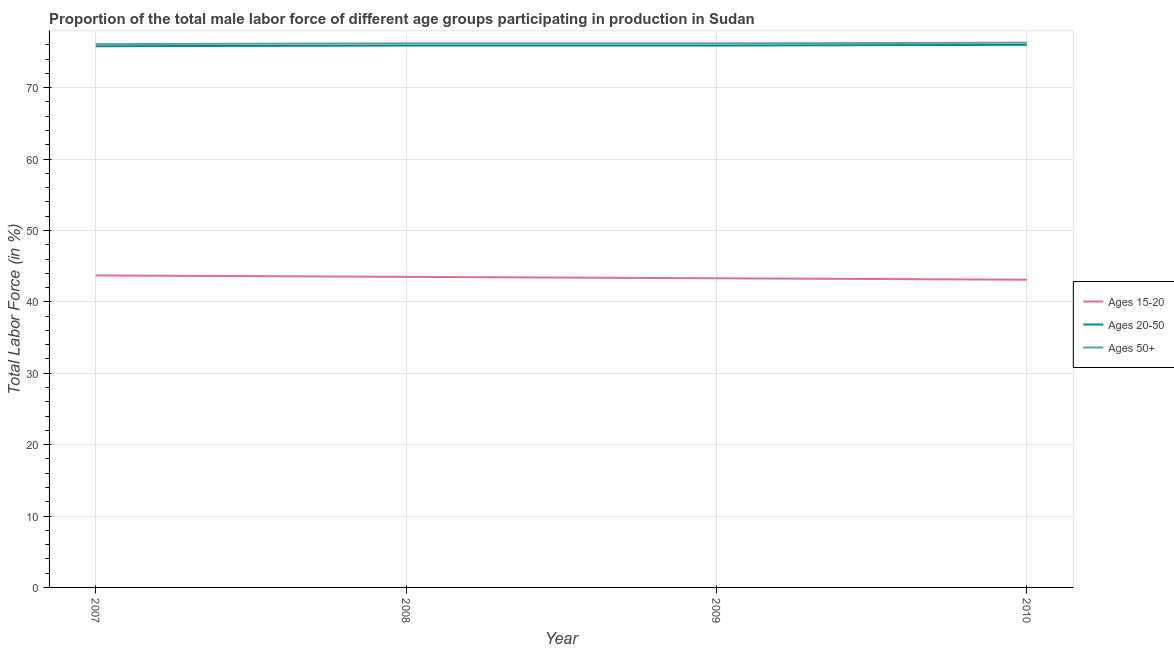What is the percentage of male labor force within the age group 15-20 in 2008?
Give a very brief answer. 43.5. Across all years, what is the maximum percentage of male labor force within the age group 20-50?
Provide a short and direct response. 76. Across all years, what is the minimum percentage of male labor force within the age group 20-50?
Your response must be concise. 75.8. In which year was the percentage of male labor force within the age group 20-50 minimum?
Offer a very short reply. 2007. What is the total percentage of male labor force above age 50 in the graph?
Keep it short and to the point. 304.8. What is the difference between the percentage of male labor force above age 50 in 2009 and that in 2010?
Make the answer very short. -0.1. What is the difference between the percentage of male labor force above age 50 in 2007 and the percentage of male labor force within the age group 20-50 in 2008?
Give a very brief answer. 0.2. What is the average percentage of male labor force above age 50 per year?
Offer a very short reply. 76.2. In the year 2008, what is the difference between the percentage of male labor force within the age group 15-20 and percentage of male labor force within the age group 20-50?
Provide a succinct answer. -32.4. In how many years, is the percentage of male labor force above age 50 greater than 20 %?
Make the answer very short. 4. What is the ratio of the percentage of male labor force within the age group 20-50 in 2007 to that in 2010?
Your response must be concise. 1. Is the percentage of male labor force within the age group 20-50 in 2009 less than that in 2010?
Give a very brief answer. Yes. Is the difference between the percentage of male labor force within the age group 15-20 in 2007 and 2010 greater than the difference between the percentage of male labor force within the age group 20-50 in 2007 and 2010?
Keep it short and to the point. Yes. What is the difference between the highest and the second highest percentage of male labor force above age 50?
Make the answer very short. 0.1. What is the difference between the highest and the lowest percentage of male labor force above age 50?
Offer a very short reply. 0.2. In how many years, is the percentage of male labor force within the age group 15-20 greater than the average percentage of male labor force within the age group 15-20 taken over all years?
Your response must be concise. 2. Does the percentage of male labor force within the age group 20-50 monotonically increase over the years?
Offer a terse response. No. Is the percentage of male labor force within the age group 20-50 strictly less than the percentage of male labor force within the age group 15-20 over the years?
Give a very brief answer. No. How many years are there in the graph?
Your answer should be very brief. 4. What is the difference between two consecutive major ticks on the Y-axis?
Give a very brief answer. 10. Does the graph contain any zero values?
Make the answer very short. No. Does the graph contain grids?
Your answer should be very brief. Yes. How are the legend labels stacked?
Your answer should be compact. Vertical. What is the title of the graph?
Keep it short and to the point. Proportion of the total male labor force of different age groups participating in production in Sudan. Does "Fuel" appear as one of the legend labels in the graph?
Provide a short and direct response. No. What is the Total Labor Force (in %) of Ages 15-20 in 2007?
Keep it short and to the point. 43.7. What is the Total Labor Force (in %) in Ages 20-50 in 2007?
Ensure brevity in your answer.  75.8. What is the Total Labor Force (in %) in Ages 50+ in 2007?
Provide a succinct answer. 76.1. What is the Total Labor Force (in %) of Ages 15-20 in 2008?
Keep it short and to the point. 43.5. What is the Total Labor Force (in %) of Ages 20-50 in 2008?
Offer a very short reply. 75.9. What is the Total Labor Force (in %) in Ages 50+ in 2008?
Keep it short and to the point. 76.2. What is the Total Labor Force (in %) of Ages 15-20 in 2009?
Give a very brief answer. 43.3. What is the Total Labor Force (in %) in Ages 20-50 in 2009?
Your response must be concise. 75.9. What is the Total Labor Force (in %) of Ages 50+ in 2009?
Your response must be concise. 76.2. What is the Total Labor Force (in %) in Ages 15-20 in 2010?
Provide a short and direct response. 43.1. What is the Total Labor Force (in %) of Ages 20-50 in 2010?
Provide a short and direct response. 76. What is the Total Labor Force (in %) in Ages 50+ in 2010?
Your answer should be very brief. 76.3. Across all years, what is the maximum Total Labor Force (in %) of Ages 15-20?
Make the answer very short. 43.7. Across all years, what is the maximum Total Labor Force (in %) in Ages 20-50?
Make the answer very short. 76. Across all years, what is the maximum Total Labor Force (in %) of Ages 50+?
Keep it short and to the point. 76.3. Across all years, what is the minimum Total Labor Force (in %) of Ages 15-20?
Offer a terse response. 43.1. Across all years, what is the minimum Total Labor Force (in %) in Ages 20-50?
Your answer should be compact. 75.8. Across all years, what is the minimum Total Labor Force (in %) of Ages 50+?
Provide a succinct answer. 76.1. What is the total Total Labor Force (in %) in Ages 15-20 in the graph?
Your answer should be very brief. 173.6. What is the total Total Labor Force (in %) of Ages 20-50 in the graph?
Make the answer very short. 303.6. What is the total Total Labor Force (in %) in Ages 50+ in the graph?
Your answer should be very brief. 304.8. What is the difference between the Total Labor Force (in %) in Ages 15-20 in 2007 and that in 2008?
Your answer should be compact. 0.2. What is the difference between the Total Labor Force (in %) of Ages 20-50 in 2007 and that in 2009?
Offer a very short reply. -0.1. What is the difference between the Total Labor Force (in %) in Ages 50+ in 2007 and that in 2009?
Provide a short and direct response. -0.1. What is the difference between the Total Labor Force (in %) in Ages 15-20 in 2007 and that in 2010?
Your answer should be compact. 0.6. What is the difference between the Total Labor Force (in %) in Ages 20-50 in 2007 and that in 2010?
Ensure brevity in your answer.  -0.2. What is the difference between the Total Labor Force (in %) of Ages 50+ in 2007 and that in 2010?
Provide a succinct answer. -0.2. What is the difference between the Total Labor Force (in %) of Ages 15-20 in 2008 and that in 2009?
Your answer should be very brief. 0.2. What is the difference between the Total Labor Force (in %) of Ages 50+ in 2008 and that in 2009?
Your answer should be very brief. 0. What is the difference between the Total Labor Force (in %) in Ages 15-20 in 2008 and that in 2010?
Keep it short and to the point. 0.4. What is the difference between the Total Labor Force (in %) of Ages 20-50 in 2008 and that in 2010?
Make the answer very short. -0.1. What is the difference between the Total Labor Force (in %) in Ages 15-20 in 2009 and that in 2010?
Provide a succinct answer. 0.2. What is the difference between the Total Labor Force (in %) of Ages 20-50 in 2009 and that in 2010?
Ensure brevity in your answer.  -0.1. What is the difference between the Total Labor Force (in %) in Ages 15-20 in 2007 and the Total Labor Force (in %) in Ages 20-50 in 2008?
Provide a succinct answer. -32.2. What is the difference between the Total Labor Force (in %) in Ages 15-20 in 2007 and the Total Labor Force (in %) in Ages 50+ in 2008?
Offer a terse response. -32.5. What is the difference between the Total Labor Force (in %) of Ages 15-20 in 2007 and the Total Labor Force (in %) of Ages 20-50 in 2009?
Ensure brevity in your answer.  -32.2. What is the difference between the Total Labor Force (in %) of Ages 15-20 in 2007 and the Total Labor Force (in %) of Ages 50+ in 2009?
Ensure brevity in your answer.  -32.5. What is the difference between the Total Labor Force (in %) of Ages 15-20 in 2007 and the Total Labor Force (in %) of Ages 20-50 in 2010?
Your answer should be compact. -32.3. What is the difference between the Total Labor Force (in %) of Ages 15-20 in 2007 and the Total Labor Force (in %) of Ages 50+ in 2010?
Give a very brief answer. -32.6. What is the difference between the Total Labor Force (in %) of Ages 15-20 in 2008 and the Total Labor Force (in %) of Ages 20-50 in 2009?
Offer a terse response. -32.4. What is the difference between the Total Labor Force (in %) of Ages 15-20 in 2008 and the Total Labor Force (in %) of Ages 50+ in 2009?
Your answer should be compact. -32.7. What is the difference between the Total Labor Force (in %) in Ages 15-20 in 2008 and the Total Labor Force (in %) in Ages 20-50 in 2010?
Your answer should be compact. -32.5. What is the difference between the Total Labor Force (in %) in Ages 15-20 in 2008 and the Total Labor Force (in %) in Ages 50+ in 2010?
Your answer should be very brief. -32.8. What is the difference between the Total Labor Force (in %) in Ages 15-20 in 2009 and the Total Labor Force (in %) in Ages 20-50 in 2010?
Keep it short and to the point. -32.7. What is the difference between the Total Labor Force (in %) of Ages 15-20 in 2009 and the Total Labor Force (in %) of Ages 50+ in 2010?
Your answer should be very brief. -33. What is the average Total Labor Force (in %) in Ages 15-20 per year?
Ensure brevity in your answer.  43.4. What is the average Total Labor Force (in %) in Ages 20-50 per year?
Make the answer very short. 75.9. What is the average Total Labor Force (in %) in Ages 50+ per year?
Your response must be concise. 76.2. In the year 2007, what is the difference between the Total Labor Force (in %) of Ages 15-20 and Total Labor Force (in %) of Ages 20-50?
Ensure brevity in your answer.  -32.1. In the year 2007, what is the difference between the Total Labor Force (in %) of Ages 15-20 and Total Labor Force (in %) of Ages 50+?
Make the answer very short. -32.4. In the year 2007, what is the difference between the Total Labor Force (in %) of Ages 20-50 and Total Labor Force (in %) of Ages 50+?
Your answer should be very brief. -0.3. In the year 2008, what is the difference between the Total Labor Force (in %) of Ages 15-20 and Total Labor Force (in %) of Ages 20-50?
Offer a very short reply. -32.4. In the year 2008, what is the difference between the Total Labor Force (in %) in Ages 15-20 and Total Labor Force (in %) in Ages 50+?
Your answer should be compact. -32.7. In the year 2008, what is the difference between the Total Labor Force (in %) in Ages 20-50 and Total Labor Force (in %) in Ages 50+?
Offer a very short reply. -0.3. In the year 2009, what is the difference between the Total Labor Force (in %) of Ages 15-20 and Total Labor Force (in %) of Ages 20-50?
Provide a succinct answer. -32.6. In the year 2009, what is the difference between the Total Labor Force (in %) in Ages 15-20 and Total Labor Force (in %) in Ages 50+?
Your answer should be very brief. -32.9. In the year 2010, what is the difference between the Total Labor Force (in %) in Ages 15-20 and Total Labor Force (in %) in Ages 20-50?
Provide a short and direct response. -32.9. In the year 2010, what is the difference between the Total Labor Force (in %) in Ages 15-20 and Total Labor Force (in %) in Ages 50+?
Keep it short and to the point. -33.2. In the year 2010, what is the difference between the Total Labor Force (in %) in Ages 20-50 and Total Labor Force (in %) in Ages 50+?
Your answer should be very brief. -0.3. What is the ratio of the Total Labor Force (in %) in Ages 15-20 in 2007 to that in 2008?
Ensure brevity in your answer.  1. What is the ratio of the Total Labor Force (in %) of Ages 20-50 in 2007 to that in 2008?
Your answer should be very brief. 1. What is the ratio of the Total Labor Force (in %) of Ages 15-20 in 2007 to that in 2009?
Your answer should be compact. 1.01. What is the ratio of the Total Labor Force (in %) of Ages 15-20 in 2007 to that in 2010?
Your answer should be compact. 1.01. What is the ratio of the Total Labor Force (in %) of Ages 50+ in 2007 to that in 2010?
Offer a terse response. 1. What is the ratio of the Total Labor Force (in %) in Ages 50+ in 2008 to that in 2009?
Provide a succinct answer. 1. What is the ratio of the Total Labor Force (in %) of Ages 15-20 in 2008 to that in 2010?
Make the answer very short. 1.01. What is the ratio of the Total Labor Force (in %) in Ages 20-50 in 2008 to that in 2010?
Make the answer very short. 1. What is the ratio of the Total Labor Force (in %) of Ages 20-50 in 2009 to that in 2010?
Offer a terse response. 1. What is the ratio of the Total Labor Force (in %) of Ages 50+ in 2009 to that in 2010?
Offer a very short reply. 1. What is the difference between the highest and the second highest Total Labor Force (in %) of Ages 20-50?
Your response must be concise. 0.1. What is the difference between the highest and the second highest Total Labor Force (in %) in Ages 50+?
Provide a short and direct response. 0.1. 